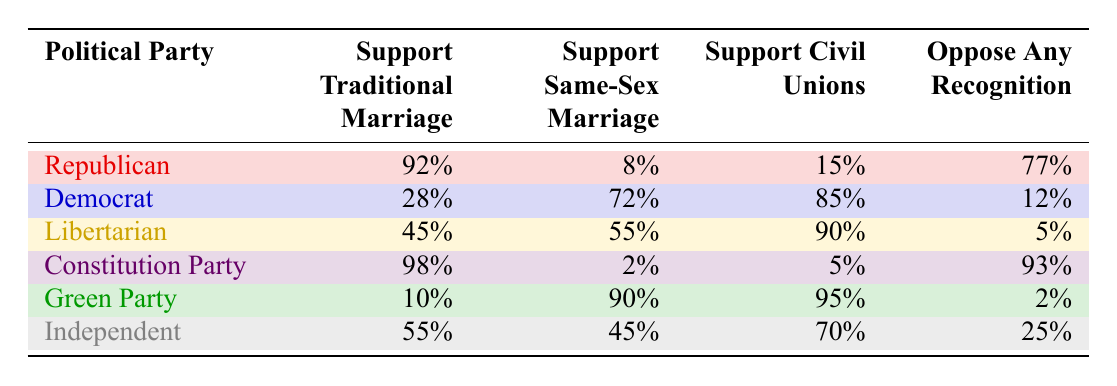What percentage of Democrats support traditional marriage? According to the table, 28% of Democrats support traditional marriage. This is directly stated in the "Support Traditional Marriage" column next to the "Democrat" row.
Answer: 28% Which political party has the highest support for traditional marriage? From the table, the Constitution Party has the highest support for traditional marriage at 98%, as shown in the "Support Traditional Marriage" column.
Answer: Constitution Party How many political parties have more than 90% support for civil unions? By examining the "Support Civil Unions" column, the Constitution Party (5%) and the Green Party (95%) are the only parties with more than 90% support for civil unions. Therefore, there are 3 parties above 90% for civil unions.
Answer: 3 Is it true that the majority of Republicans oppose any recognition of same-sex unions? Looking at the table, 77% of Republicans oppose any recognition, which does indicate a majority. Hence, the statement is true.
Answer: Yes What is the difference in support for same-sex marriage between the Democrat and Libertarian parties? The Democrats support same-sex marriage at 72%, while Libertarians support it at 55%. The difference is calculated as 72% - 55% = 17%. Thus, Democrats have 17% more support for same-sex marriage than Libertarians.
Answer: 17% Does any political party have less than 10% support for traditional marriage? By reviewing the table, the Green Party shows only 10% support for traditional marriage, which is not less than 10%, hence the answer is no.
Answer: No What is the median percentage of support for civil unions among all parties listed? To find the median support for civil unions, we first list the support percentages in ascending order: 5%, 15%, 70%, 85%, 90%, 95%. Since there are 6 values, the median is the average of the 3rd and 4th values: (70% + 85%)/2 = 77.5%.
Answer: 77.5% How many political parties have less than 50% support for traditional marriage? Checking the "Support Traditional Marriage" column, the only parties with less than 50% support are Democrats (28%) and the Green Party (10%). Thus, there are 2 parties with this characteristic.
Answer: 2 